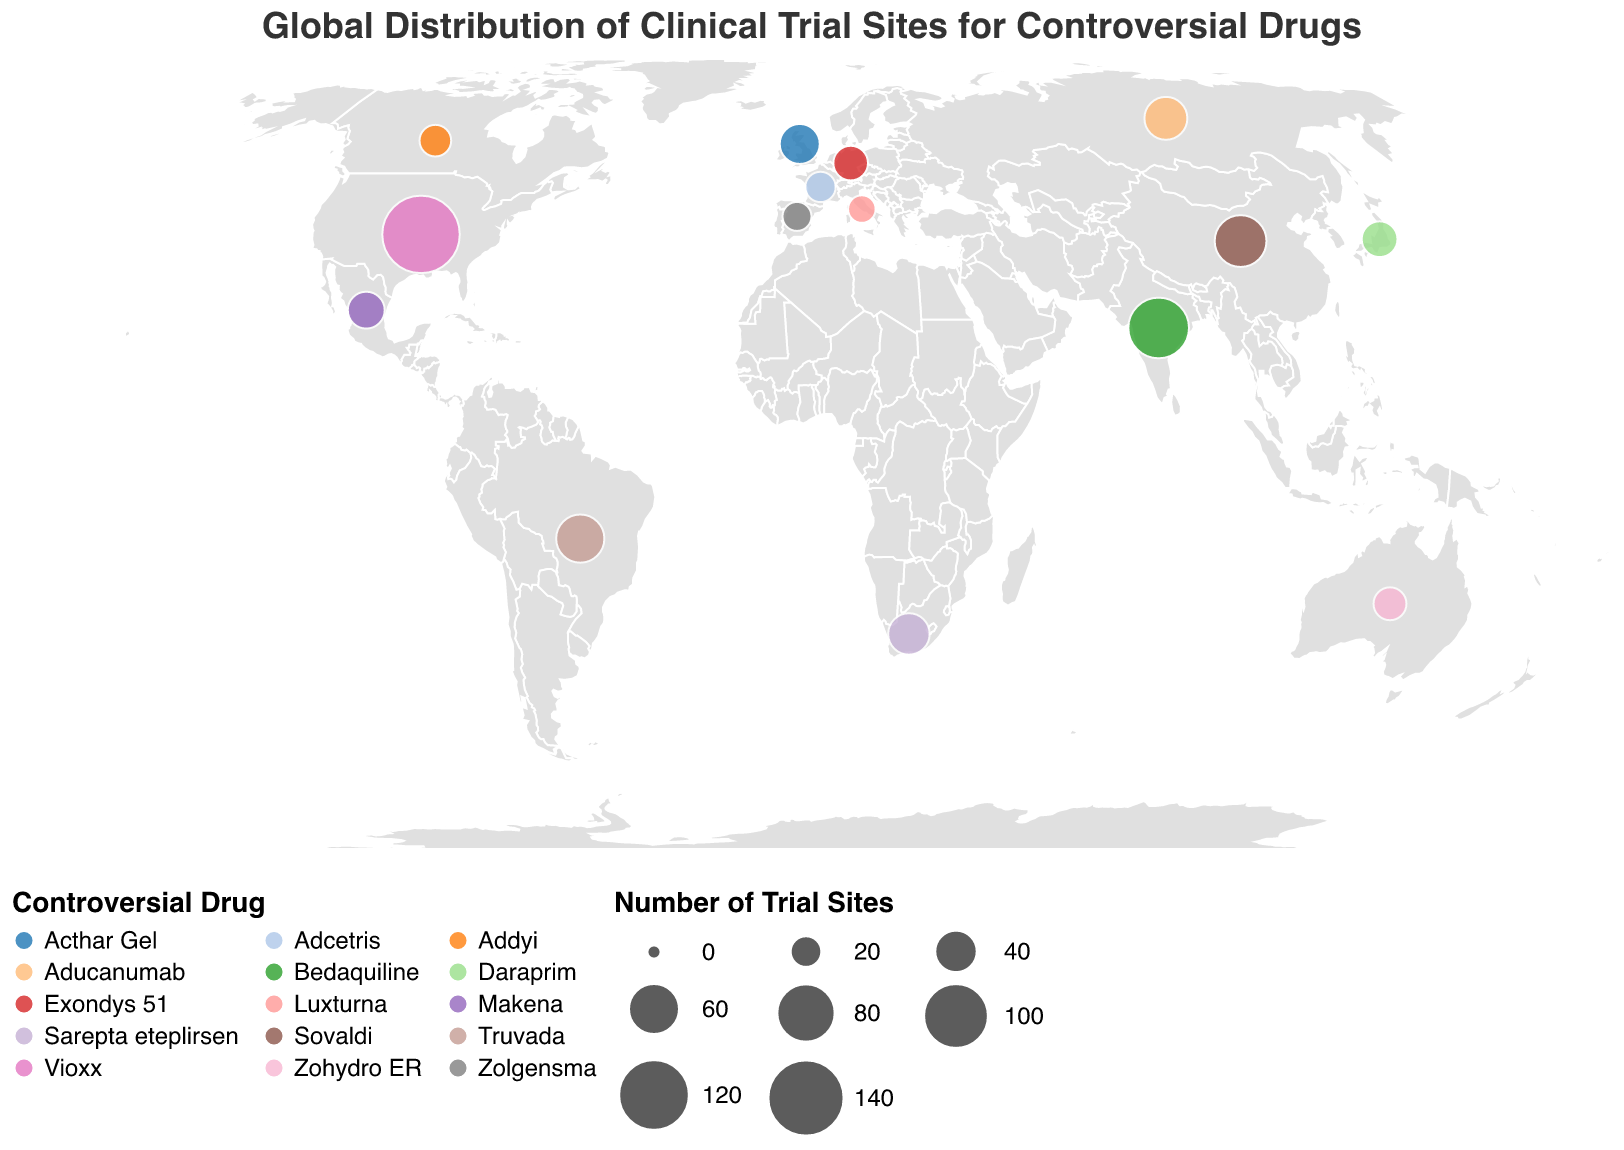What is the total number of clinical trial sites for the drugs listed? Add the "Number of Trial Sites" values for all the countries: 145 (US) + 87 (India) + 62 (China) + 53 (Brazil) + 41 (Russia) + 38 (South Africa) + 35 (UK) + 29 (Mexico) + 27 (Japan) + 25 (Germany) + 22 (Australia) + 20 (Canada) + 18 (France) + 16 (Spain) + 14 (Italy) = 632
Answer: 632 Which country has the highest number of clinical trial sites for a controversial drug? Look at the circles on the map and identify the largest circle. According to the data, the United States has the highest number of clinical trial sites at 145.
Answer: United States What controversial drug is being tested in India? Find India on the map and look at the tooltip information provided. The controversial drug being tested in India is Bedaquiline.
Answer: Bedaquiline How many clinical trial sites are there in Europe? Identify the countries in Europe (United Kingdom, Germany, France, Spain, Italy) and sum their trial sites: 35 (UK) + 25 (Germany) + 18 (France) + 16 (Spain) + 14 (Italy) = 108.
Answer: 108 Compare the number of clinical trial sites between Russia and Brazil. Which one has more? Find the trial sites for Russia (41) and Brazil (53). Compare the two values: Brazil has more trial sites than Russia.
Answer: Brazil What is the average number of clinical trial sites per country? Divide the total number of trial sites (632) by the number of countries (15). Average = 632 / 15 = 42.13.
Answer: 42.13 Which drugs have clinical trials in less than 30 sites in any country? Identify the drugs associated with countries having less than 30 trial sites: Mexico (Makena), Japan (Daraprim), Germany (Exondys 51), Australia (Zohydro ER), Canada (Addyi), France (Adcetris), Spain (Zolgensma), Italy (Luxturna).
Answer: Makena, Daraprim, Exondys 51, Zohydro ER, Addyi, Adcetris, Zolgensma, Luxturna 